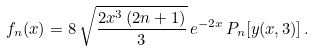<formula> <loc_0><loc_0><loc_500><loc_500>f _ { n } ( x ) = 8 \, \sqrt { \frac { 2 x ^ { 3 } \, ( 2 n + 1 ) } { 3 } } \, e ^ { - 2 x } \, P _ { n } [ y ( x , 3 ) ] \, .</formula> 